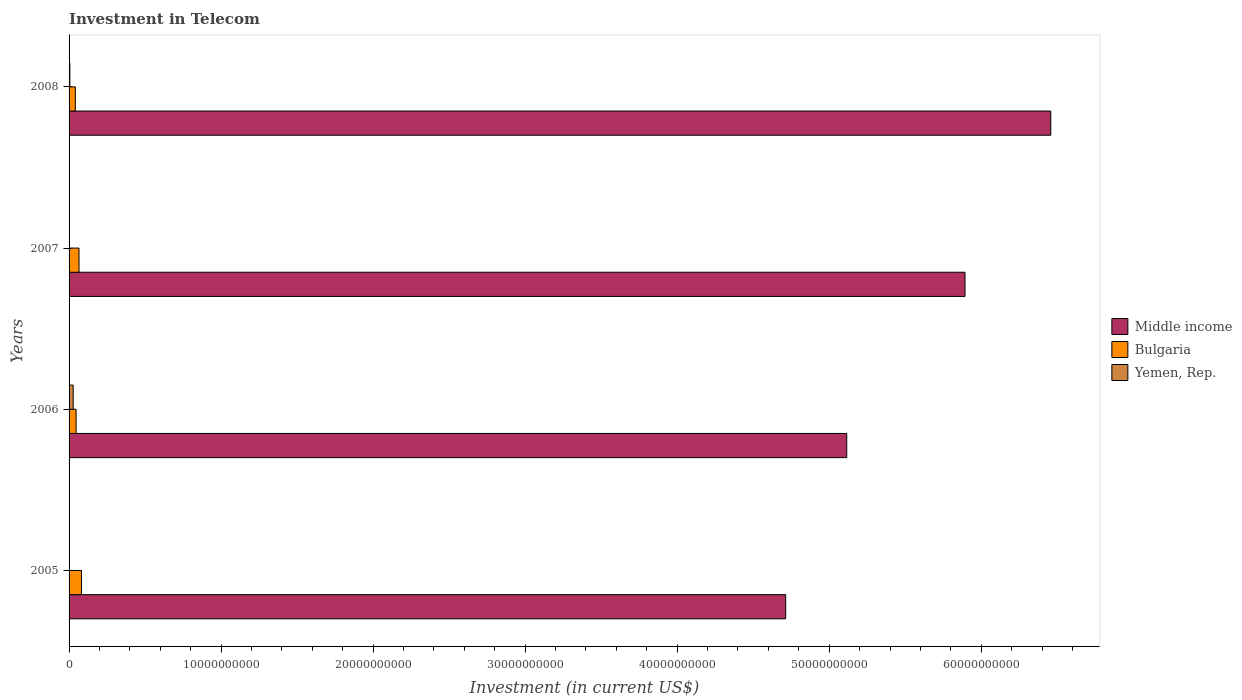Are the number of bars per tick equal to the number of legend labels?
Ensure brevity in your answer.  Yes. Are the number of bars on each tick of the Y-axis equal?
Offer a very short reply. Yes. How many bars are there on the 3rd tick from the top?
Your answer should be very brief. 3. How many bars are there on the 4th tick from the bottom?
Make the answer very short. 3. In how many cases, is the number of bars for a given year not equal to the number of legend labels?
Offer a terse response. 0. What is the amount invested in telecom in Yemen, Rep. in 2005?
Provide a short and direct response. 1.88e+07. Across all years, what is the maximum amount invested in telecom in Bulgaria?
Give a very brief answer. 8.17e+08. Across all years, what is the minimum amount invested in telecom in Yemen, Rep.?
Your answer should be very brief. 1.88e+07. What is the total amount invested in telecom in Middle income in the graph?
Provide a short and direct response. 2.22e+11. What is the difference between the amount invested in telecom in Middle income in 2005 and that in 2008?
Ensure brevity in your answer.  -1.74e+1. What is the difference between the amount invested in telecom in Yemen, Rep. in 2008 and the amount invested in telecom in Bulgaria in 2007?
Your answer should be compact. -6.04e+08. What is the average amount invested in telecom in Bulgaria per year?
Provide a short and direct response. 5.86e+08. In the year 2008, what is the difference between the amount invested in telecom in Middle income and amount invested in telecom in Yemen, Rep.?
Offer a terse response. 6.45e+1. In how many years, is the amount invested in telecom in Yemen, Rep. greater than 48000000000 US$?
Ensure brevity in your answer.  0. What is the ratio of the amount invested in telecom in Yemen, Rep. in 2006 to that in 2007?
Provide a short and direct response. 12.71. Is the difference between the amount invested in telecom in Middle income in 2007 and 2008 greater than the difference between the amount invested in telecom in Yemen, Rep. in 2007 and 2008?
Offer a very short reply. No. What is the difference between the highest and the second highest amount invested in telecom in Bulgaria?
Provide a succinct answer. 1.63e+08. What is the difference between the highest and the lowest amount invested in telecom in Middle income?
Provide a succinct answer. 1.74e+1. In how many years, is the amount invested in telecom in Yemen, Rep. greater than the average amount invested in telecom in Yemen, Rep. taken over all years?
Keep it short and to the point. 1. Is the sum of the amount invested in telecom in Yemen, Rep. in 2006 and 2007 greater than the maximum amount invested in telecom in Bulgaria across all years?
Your answer should be very brief. No. What does the 1st bar from the top in 2007 represents?
Ensure brevity in your answer.  Yemen, Rep. What does the 1st bar from the bottom in 2008 represents?
Offer a terse response. Middle income. Is it the case that in every year, the sum of the amount invested in telecom in Bulgaria and amount invested in telecom in Middle income is greater than the amount invested in telecom in Yemen, Rep.?
Provide a short and direct response. Yes. What is the difference between two consecutive major ticks on the X-axis?
Provide a succinct answer. 1.00e+1. How many legend labels are there?
Make the answer very short. 3. What is the title of the graph?
Provide a succinct answer. Investment in Telecom. Does "Denmark" appear as one of the legend labels in the graph?
Provide a succinct answer. No. What is the label or title of the X-axis?
Provide a succinct answer. Investment (in current US$). What is the label or title of the Y-axis?
Keep it short and to the point. Years. What is the Investment (in current US$) in Middle income in 2005?
Make the answer very short. 4.71e+1. What is the Investment (in current US$) in Bulgaria in 2005?
Your answer should be compact. 8.17e+08. What is the Investment (in current US$) in Yemen, Rep. in 2005?
Offer a terse response. 1.88e+07. What is the Investment (in current US$) of Middle income in 2006?
Give a very brief answer. 5.12e+1. What is the Investment (in current US$) in Bulgaria in 2006?
Offer a terse response. 4.62e+08. What is the Investment (in current US$) in Yemen, Rep. in 2006?
Offer a very short reply. 2.71e+08. What is the Investment (in current US$) in Middle income in 2007?
Offer a very short reply. 5.89e+1. What is the Investment (in current US$) in Bulgaria in 2007?
Provide a short and direct response. 6.54e+08. What is the Investment (in current US$) of Yemen, Rep. in 2007?
Your answer should be compact. 2.13e+07. What is the Investment (in current US$) of Middle income in 2008?
Give a very brief answer. 6.46e+1. What is the Investment (in current US$) in Bulgaria in 2008?
Your response must be concise. 4.11e+08. What is the Investment (in current US$) in Yemen, Rep. in 2008?
Your answer should be compact. 5.01e+07. Across all years, what is the maximum Investment (in current US$) of Middle income?
Provide a succinct answer. 6.46e+1. Across all years, what is the maximum Investment (in current US$) of Bulgaria?
Offer a terse response. 8.17e+08. Across all years, what is the maximum Investment (in current US$) in Yemen, Rep.?
Offer a very short reply. 2.71e+08. Across all years, what is the minimum Investment (in current US$) of Middle income?
Ensure brevity in your answer.  4.71e+1. Across all years, what is the minimum Investment (in current US$) of Bulgaria?
Offer a terse response. 4.11e+08. Across all years, what is the minimum Investment (in current US$) in Yemen, Rep.?
Offer a very short reply. 1.88e+07. What is the total Investment (in current US$) in Middle income in the graph?
Provide a succinct answer. 2.22e+11. What is the total Investment (in current US$) of Bulgaria in the graph?
Offer a terse response. 2.34e+09. What is the total Investment (in current US$) of Yemen, Rep. in the graph?
Provide a short and direct response. 3.61e+08. What is the difference between the Investment (in current US$) in Middle income in 2005 and that in 2006?
Offer a terse response. -4.02e+09. What is the difference between the Investment (in current US$) in Bulgaria in 2005 and that in 2006?
Your answer should be very brief. 3.55e+08. What is the difference between the Investment (in current US$) of Yemen, Rep. in 2005 and that in 2006?
Keep it short and to the point. -2.52e+08. What is the difference between the Investment (in current US$) in Middle income in 2005 and that in 2007?
Give a very brief answer. -1.18e+1. What is the difference between the Investment (in current US$) in Bulgaria in 2005 and that in 2007?
Offer a very short reply. 1.63e+08. What is the difference between the Investment (in current US$) of Yemen, Rep. in 2005 and that in 2007?
Make the answer very short. -2.50e+06. What is the difference between the Investment (in current US$) of Middle income in 2005 and that in 2008?
Your response must be concise. -1.74e+1. What is the difference between the Investment (in current US$) in Bulgaria in 2005 and that in 2008?
Keep it short and to the point. 4.06e+08. What is the difference between the Investment (in current US$) in Yemen, Rep. in 2005 and that in 2008?
Your answer should be very brief. -3.13e+07. What is the difference between the Investment (in current US$) of Middle income in 2006 and that in 2007?
Your answer should be compact. -7.78e+09. What is the difference between the Investment (in current US$) of Bulgaria in 2006 and that in 2007?
Provide a succinct answer. -1.92e+08. What is the difference between the Investment (in current US$) of Yemen, Rep. in 2006 and that in 2007?
Your answer should be compact. 2.50e+08. What is the difference between the Investment (in current US$) of Middle income in 2006 and that in 2008?
Offer a very short reply. -1.34e+1. What is the difference between the Investment (in current US$) of Bulgaria in 2006 and that in 2008?
Offer a terse response. 5.12e+07. What is the difference between the Investment (in current US$) in Yemen, Rep. in 2006 and that in 2008?
Your answer should be compact. 2.21e+08. What is the difference between the Investment (in current US$) of Middle income in 2007 and that in 2008?
Provide a short and direct response. -5.64e+09. What is the difference between the Investment (in current US$) in Bulgaria in 2007 and that in 2008?
Your response must be concise. 2.43e+08. What is the difference between the Investment (in current US$) of Yemen, Rep. in 2007 and that in 2008?
Offer a very short reply. -2.88e+07. What is the difference between the Investment (in current US$) in Middle income in 2005 and the Investment (in current US$) in Bulgaria in 2006?
Ensure brevity in your answer.  4.67e+1. What is the difference between the Investment (in current US$) in Middle income in 2005 and the Investment (in current US$) in Yemen, Rep. in 2006?
Your response must be concise. 4.69e+1. What is the difference between the Investment (in current US$) in Bulgaria in 2005 and the Investment (in current US$) in Yemen, Rep. in 2006?
Your answer should be very brief. 5.46e+08. What is the difference between the Investment (in current US$) in Middle income in 2005 and the Investment (in current US$) in Bulgaria in 2007?
Offer a terse response. 4.65e+1. What is the difference between the Investment (in current US$) of Middle income in 2005 and the Investment (in current US$) of Yemen, Rep. in 2007?
Give a very brief answer. 4.71e+1. What is the difference between the Investment (in current US$) of Bulgaria in 2005 and the Investment (in current US$) of Yemen, Rep. in 2007?
Offer a terse response. 7.96e+08. What is the difference between the Investment (in current US$) of Middle income in 2005 and the Investment (in current US$) of Bulgaria in 2008?
Your answer should be compact. 4.67e+1. What is the difference between the Investment (in current US$) of Middle income in 2005 and the Investment (in current US$) of Yemen, Rep. in 2008?
Ensure brevity in your answer.  4.71e+1. What is the difference between the Investment (in current US$) of Bulgaria in 2005 and the Investment (in current US$) of Yemen, Rep. in 2008?
Provide a succinct answer. 7.67e+08. What is the difference between the Investment (in current US$) in Middle income in 2006 and the Investment (in current US$) in Bulgaria in 2007?
Your answer should be compact. 5.05e+1. What is the difference between the Investment (in current US$) in Middle income in 2006 and the Investment (in current US$) in Yemen, Rep. in 2007?
Your response must be concise. 5.11e+1. What is the difference between the Investment (in current US$) of Bulgaria in 2006 and the Investment (in current US$) of Yemen, Rep. in 2007?
Keep it short and to the point. 4.41e+08. What is the difference between the Investment (in current US$) in Middle income in 2006 and the Investment (in current US$) in Bulgaria in 2008?
Keep it short and to the point. 5.07e+1. What is the difference between the Investment (in current US$) of Middle income in 2006 and the Investment (in current US$) of Yemen, Rep. in 2008?
Give a very brief answer. 5.11e+1. What is the difference between the Investment (in current US$) in Bulgaria in 2006 and the Investment (in current US$) in Yemen, Rep. in 2008?
Your answer should be very brief. 4.12e+08. What is the difference between the Investment (in current US$) in Middle income in 2007 and the Investment (in current US$) in Bulgaria in 2008?
Your answer should be compact. 5.85e+1. What is the difference between the Investment (in current US$) of Middle income in 2007 and the Investment (in current US$) of Yemen, Rep. in 2008?
Give a very brief answer. 5.89e+1. What is the difference between the Investment (in current US$) of Bulgaria in 2007 and the Investment (in current US$) of Yemen, Rep. in 2008?
Your answer should be very brief. 6.04e+08. What is the average Investment (in current US$) in Middle income per year?
Your response must be concise. 5.54e+1. What is the average Investment (in current US$) in Bulgaria per year?
Provide a short and direct response. 5.86e+08. What is the average Investment (in current US$) of Yemen, Rep. per year?
Offer a terse response. 9.02e+07. In the year 2005, what is the difference between the Investment (in current US$) in Middle income and Investment (in current US$) in Bulgaria?
Your answer should be compact. 4.63e+1. In the year 2005, what is the difference between the Investment (in current US$) in Middle income and Investment (in current US$) in Yemen, Rep.?
Your response must be concise. 4.71e+1. In the year 2005, what is the difference between the Investment (in current US$) in Bulgaria and Investment (in current US$) in Yemen, Rep.?
Give a very brief answer. 7.98e+08. In the year 2006, what is the difference between the Investment (in current US$) of Middle income and Investment (in current US$) of Bulgaria?
Offer a very short reply. 5.07e+1. In the year 2006, what is the difference between the Investment (in current US$) in Middle income and Investment (in current US$) in Yemen, Rep.?
Keep it short and to the point. 5.09e+1. In the year 2006, what is the difference between the Investment (in current US$) of Bulgaria and Investment (in current US$) of Yemen, Rep.?
Make the answer very short. 1.91e+08. In the year 2007, what is the difference between the Investment (in current US$) in Middle income and Investment (in current US$) in Bulgaria?
Make the answer very short. 5.83e+1. In the year 2007, what is the difference between the Investment (in current US$) in Middle income and Investment (in current US$) in Yemen, Rep.?
Provide a succinct answer. 5.89e+1. In the year 2007, what is the difference between the Investment (in current US$) of Bulgaria and Investment (in current US$) of Yemen, Rep.?
Provide a succinct answer. 6.33e+08. In the year 2008, what is the difference between the Investment (in current US$) in Middle income and Investment (in current US$) in Bulgaria?
Offer a terse response. 6.42e+1. In the year 2008, what is the difference between the Investment (in current US$) in Middle income and Investment (in current US$) in Yemen, Rep.?
Provide a succinct answer. 6.45e+1. In the year 2008, what is the difference between the Investment (in current US$) in Bulgaria and Investment (in current US$) in Yemen, Rep.?
Ensure brevity in your answer.  3.61e+08. What is the ratio of the Investment (in current US$) of Middle income in 2005 to that in 2006?
Offer a very short reply. 0.92. What is the ratio of the Investment (in current US$) in Bulgaria in 2005 to that in 2006?
Offer a terse response. 1.77. What is the ratio of the Investment (in current US$) in Yemen, Rep. in 2005 to that in 2006?
Keep it short and to the point. 0.07. What is the ratio of the Investment (in current US$) in Middle income in 2005 to that in 2007?
Make the answer very short. 0.8. What is the ratio of the Investment (in current US$) in Bulgaria in 2005 to that in 2007?
Provide a short and direct response. 1.25. What is the ratio of the Investment (in current US$) of Yemen, Rep. in 2005 to that in 2007?
Provide a succinct answer. 0.88. What is the ratio of the Investment (in current US$) of Middle income in 2005 to that in 2008?
Provide a succinct answer. 0.73. What is the ratio of the Investment (in current US$) in Bulgaria in 2005 to that in 2008?
Your answer should be compact. 1.99. What is the ratio of the Investment (in current US$) in Yemen, Rep. in 2005 to that in 2008?
Offer a very short reply. 0.38. What is the ratio of the Investment (in current US$) in Middle income in 2006 to that in 2007?
Offer a very short reply. 0.87. What is the ratio of the Investment (in current US$) of Bulgaria in 2006 to that in 2007?
Your response must be concise. 0.71. What is the ratio of the Investment (in current US$) of Yemen, Rep. in 2006 to that in 2007?
Give a very brief answer. 12.71. What is the ratio of the Investment (in current US$) in Middle income in 2006 to that in 2008?
Provide a short and direct response. 0.79. What is the ratio of the Investment (in current US$) in Bulgaria in 2006 to that in 2008?
Ensure brevity in your answer.  1.12. What is the ratio of the Investment (in current US$) in Yemen, Rep. in 2006 to that in 2008?
Provide a short and direct response. 5.41. What is the ratio of the Investment (in current US$) of Middle income in 2007 to that in 2008?
Make the answer very short. 0.91. What is the ratio of the Investment (in current US$) of Bulgaria in 2007 to that in 2008?
Offer a very short reply. 1.59. What is the ratio of the Investment (in current US$) of Yemen, Rep. in 2007 to that in 2008?
Ensure brevity in your answer.  0.43. What is the difference between the highest and the second highest Investment (in current US$) of Middle income?
Your answer should be compact. 5.64e+09. What is the difference between the highest and the second highest Investment (in current US$) in Bulgaria?
Your answer should be compact. 1.63e+08. What is the difference between the highest and the second highest Investment (in current US$) in Yemen, Rep.?
Your response must be concise. 2.21e+08. What is the difference between the highest and the lowest Investment (in current US$) of Middle income?
Offer a terse response. 1.74e+1. What is the difference between the highest and the lowest Investment (in current US$) in Bulgaria?
Provide a succinct answer. 4.06e+08. What is the difference between the highest and the lowest Investment (in current US$) in Yemen, Rep.?
Make the answer very short. 2.52e+08. 